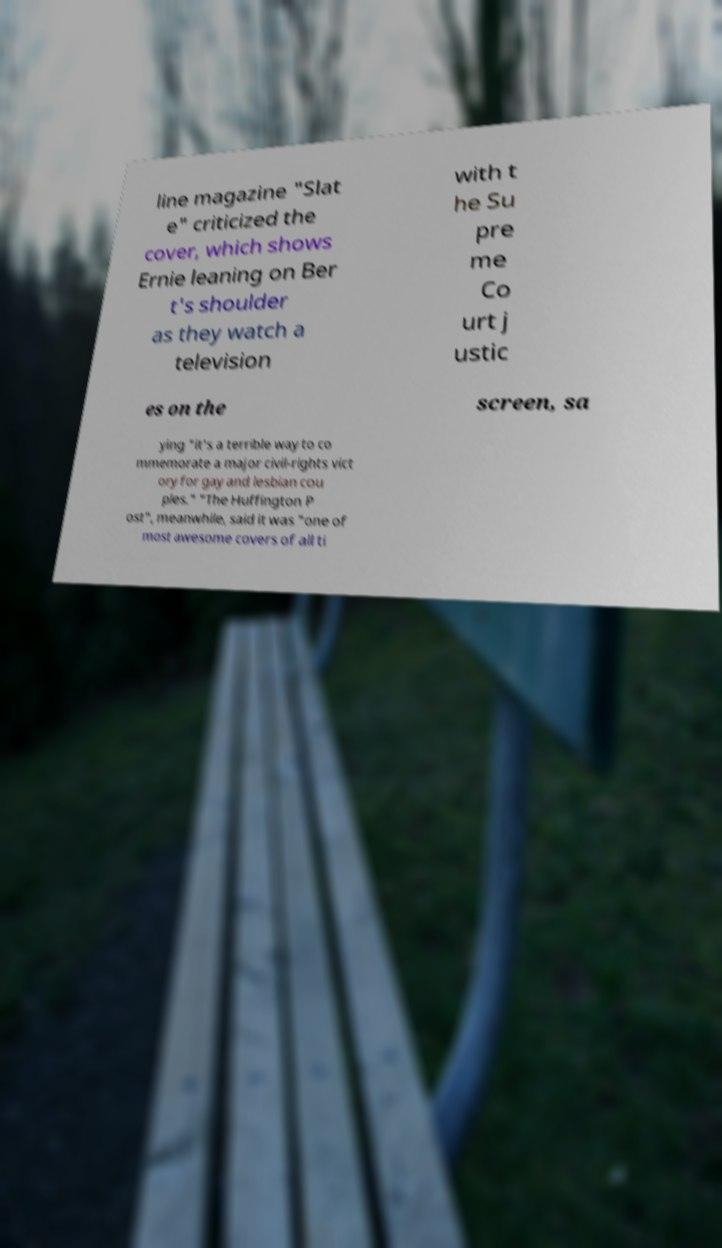Please read and relay the text visible in this image. What does it say? line magazine "Slat e" criticized the cover, which shows Ernie leaning on Ber t's shoulder as they watch a television with t he Su pre me Co urt j ustic es on the screen, sa ying "it's a terrible way to co mmemorate a major civil-rights vict ory for gay and lesbian cou ples." "The Huffington P ost", meanwhile, said it was "one of most awesome covers of all ti 